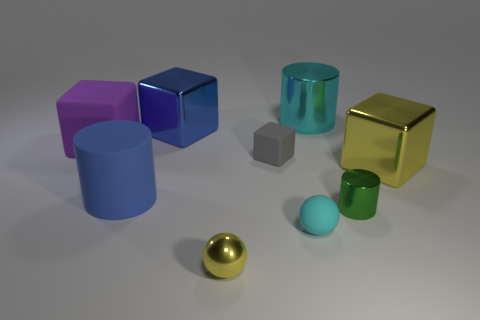Can you describe the lighting and shadows in this scene? The lighting in the scene appears to come from above, creating soft shadows underneath the objects. These shadows help convey the three-dimensionality and spatial relationships between the objects. The diffused light ensures there are no harsh shadows, which contributes to the overall calm and balanced composition of the image. 